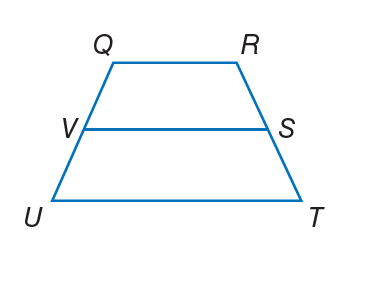Answer the mathemtical geometry problem and directly provide the correct option letter.
Question: For trapezoid Q R T U, V and S are midpoints of the legs. If R Q = 5 and V S = 11, find U T.
Choices: A: 5 B: 12 C: 17 D: 20 C 